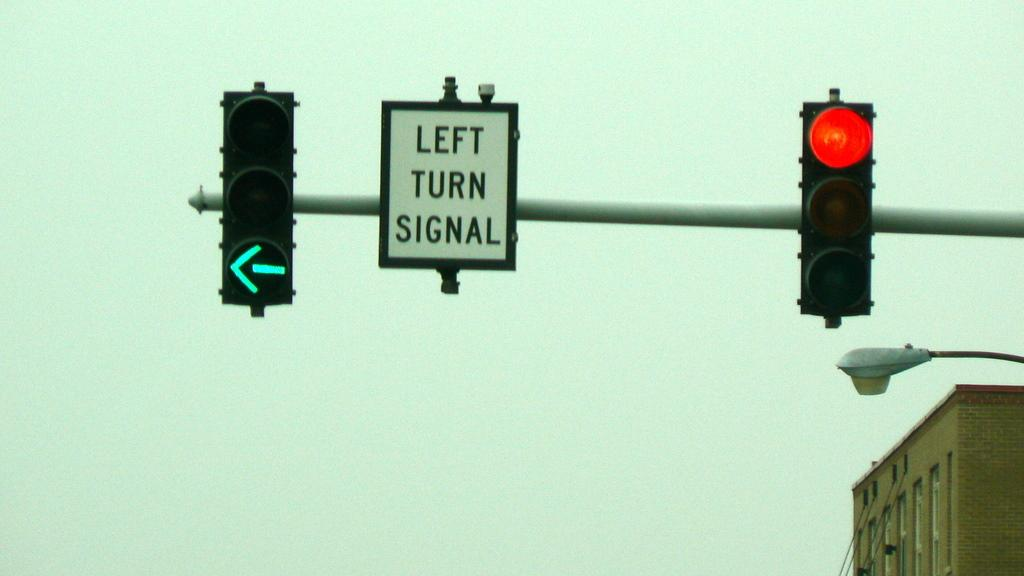<image>
Write a terse but informative summary of the picture. A traffic light with a green arrow is lit up next to a left turn signal sign. 